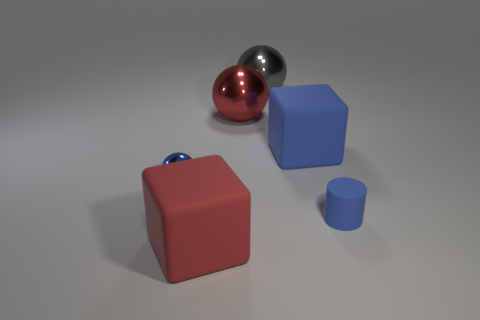Add 3 tiny matte cylinders. How many objects exist? 9 Subtract all cylinders. How many objects are left? 5 Subtract all cylinders. Subtract all large rubber cubes. How many objects are left? 3 Add 5 blue shiny things. How many blue shiny things are left? 6 Add 6 blue matte cylinders. How many blue matte cylinders exist? 7 Subtract 0 green cubes. How many objects are left? 6 